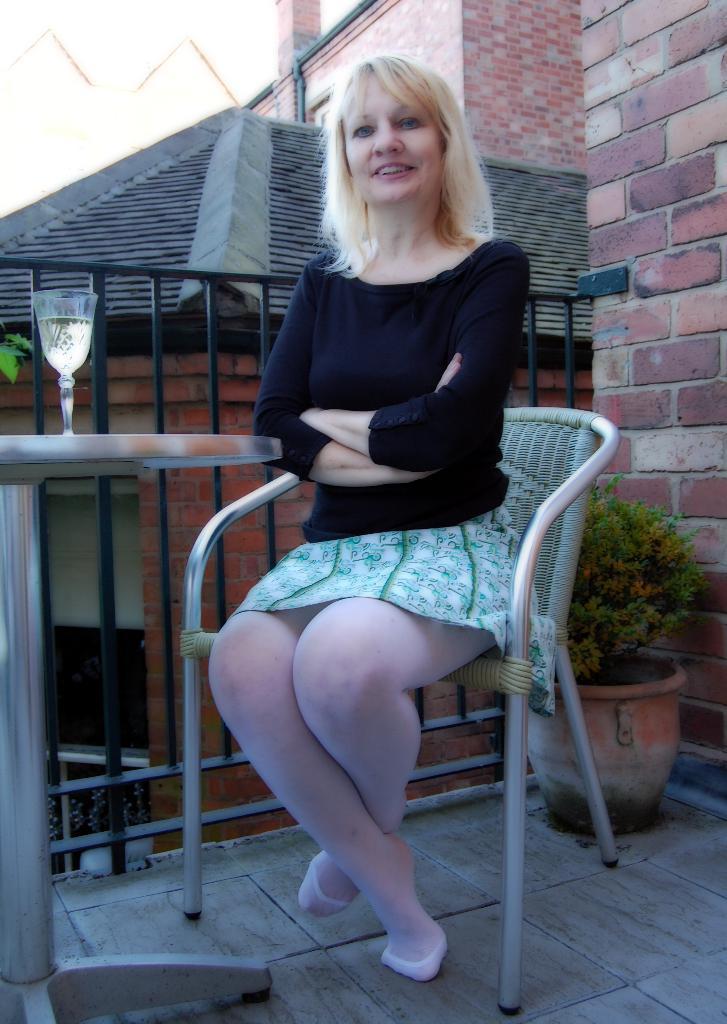Can you describe this image briefly? In the image we can see a woman wearing clothes and she is sitting on the chair and she is smiling. Here we can see the plant, table and on the table there is a wine glass. Here we can see the fence, floor and the brick wall. 